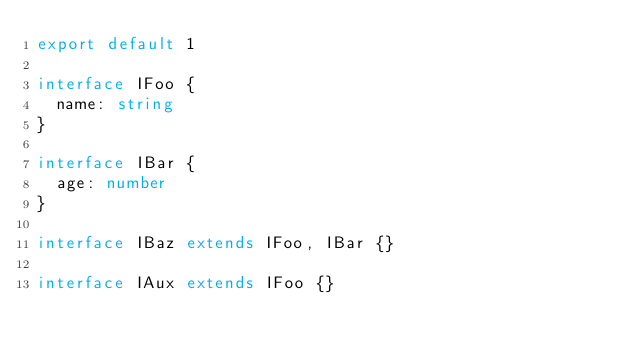<code> <loc_0><loc_0><loc_500><loc_500><_TypeScript_>export default 1

interface IFoo {
  name: string
}

interface IBar {
  age: number
}

interface IBaz extends IFoo, IBar {}

interface IAux extends IFoo {}
</code> 